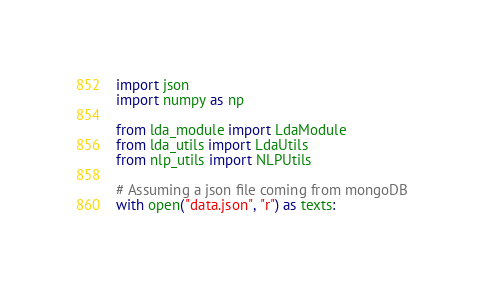<code> <loc_0><loc_0><loc_500><loc_500><_Python_>import json
import numpy as np

from lda_module import LdaModule
from lda_utils import LdaUtils
from nlp_utils import NLPUtils

# Assuming a json file coming from mongoDB
with open("data.json", "r") as texts:</code> 